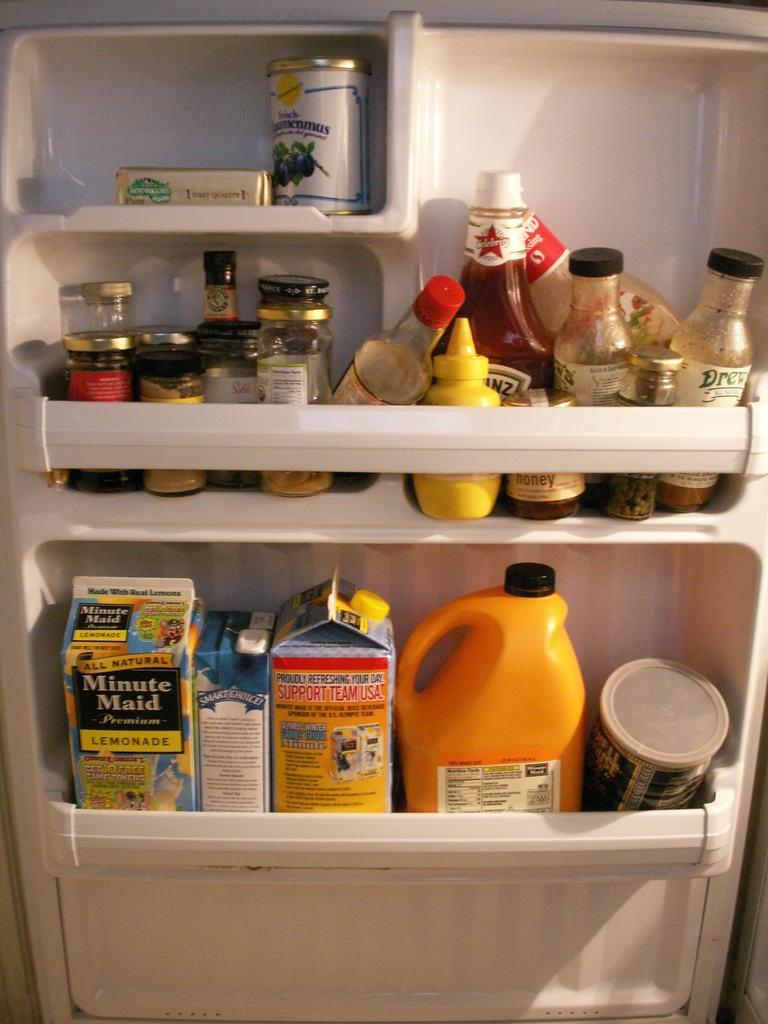Provide a one-sentence caption for the provided image. Minute Maid orange juice and other drinks and condiments sit on the door of a refrigerator. 